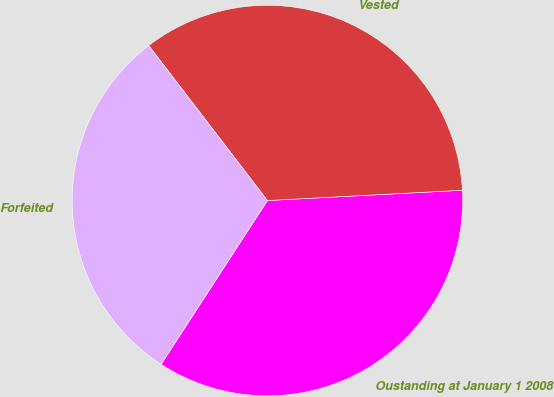Convert chart. <chart><loc_0><loc_0><loc_500><loc_500><pie_chart><fcel>Oustanding at January 1 2008<fcel>Vested<fcel>Forfeited<nl><fcel>35.0%<fcel>34.56%<fcel>30.43%<nl></chart> 